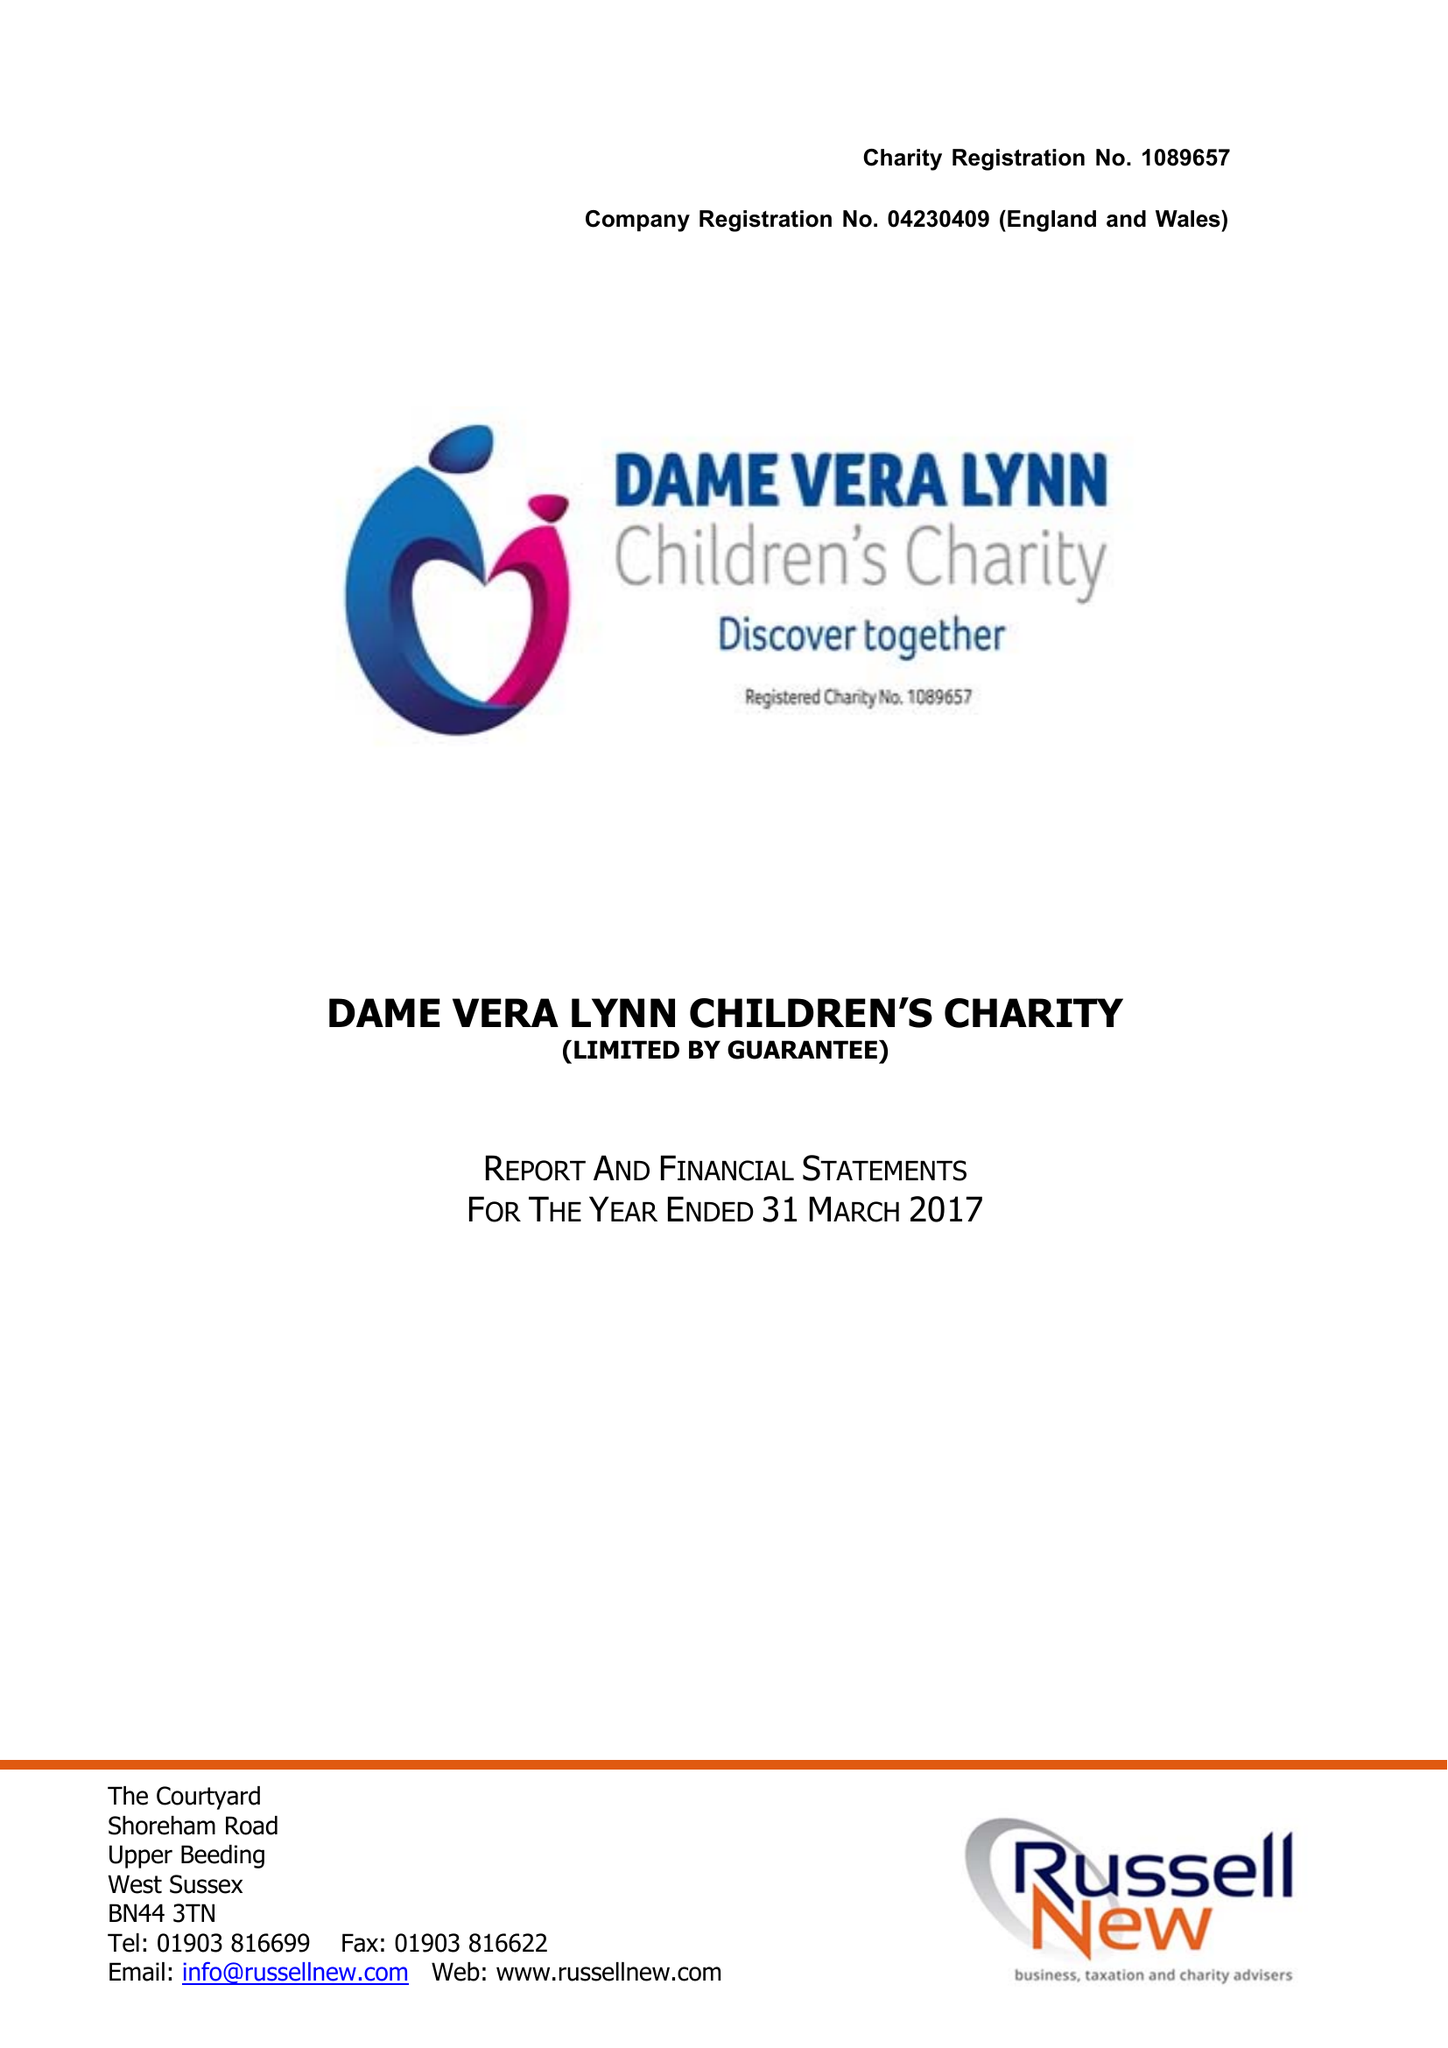What is the value for the spending_annually_in_british_pounds?
Answer the question using a single word or phrase. 266012.00 